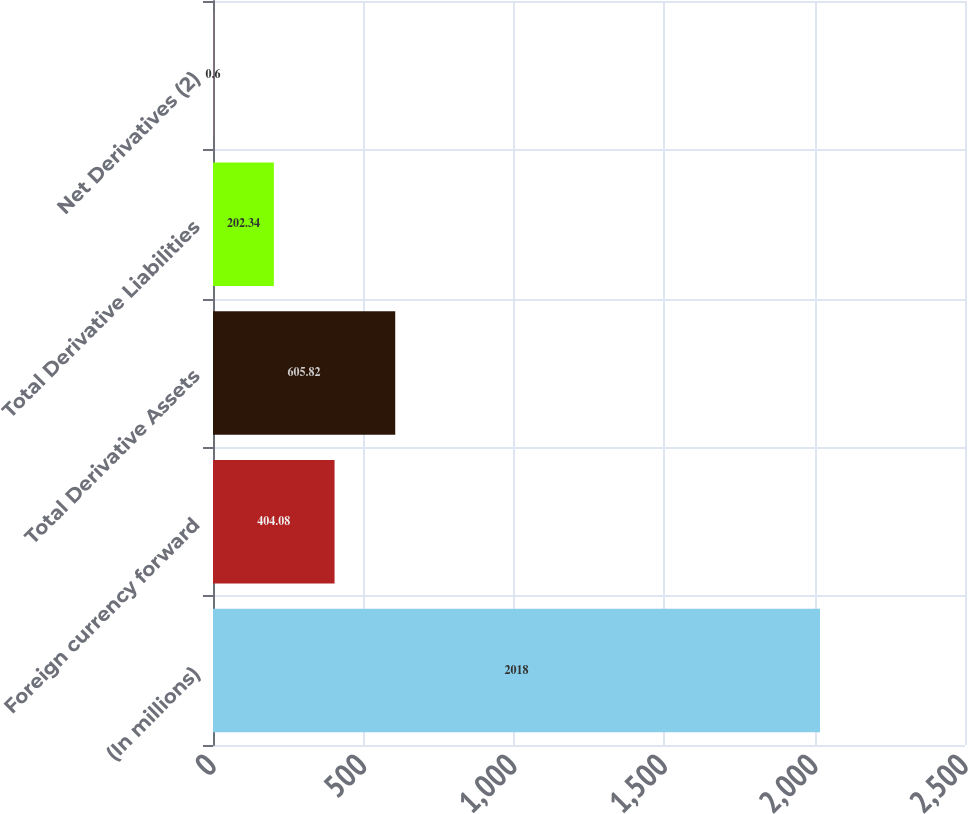<chart> <loc_0><loc_0><loc_500><loc_500><bar_chart><fcel>(In millions)<fcel>Foreign currency forward<fcel>Total Derivative Assets<fcel>Total Derivative Liabilities<fcel>Net Derivatives (2)<nl><fcel>2018<fcel>404.08<fcel>605.82<fcel>202.34<fcel>0.6<nl></chart> 